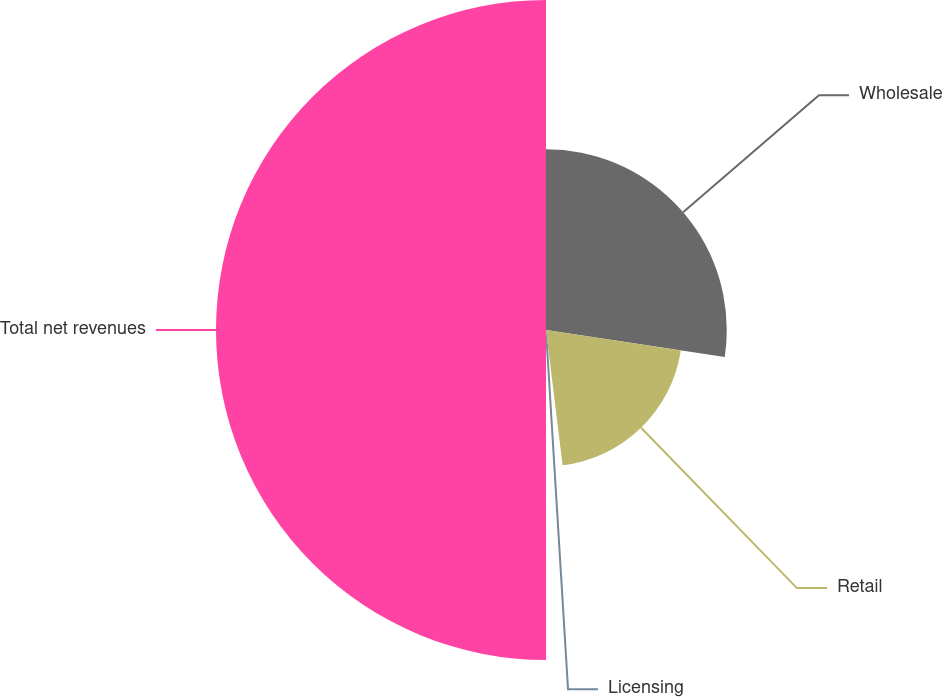<chart> <loc_0><loc_0><loc_500><loc_500><pie_chart><fcel>Wholesale<fcel>Retail<fcel>Licensing<fcel>Total net revenues<nl><fcel>27.39%<fcel>20.66%<fcel>1.94%<fcel>50.0%<nl></chart> 